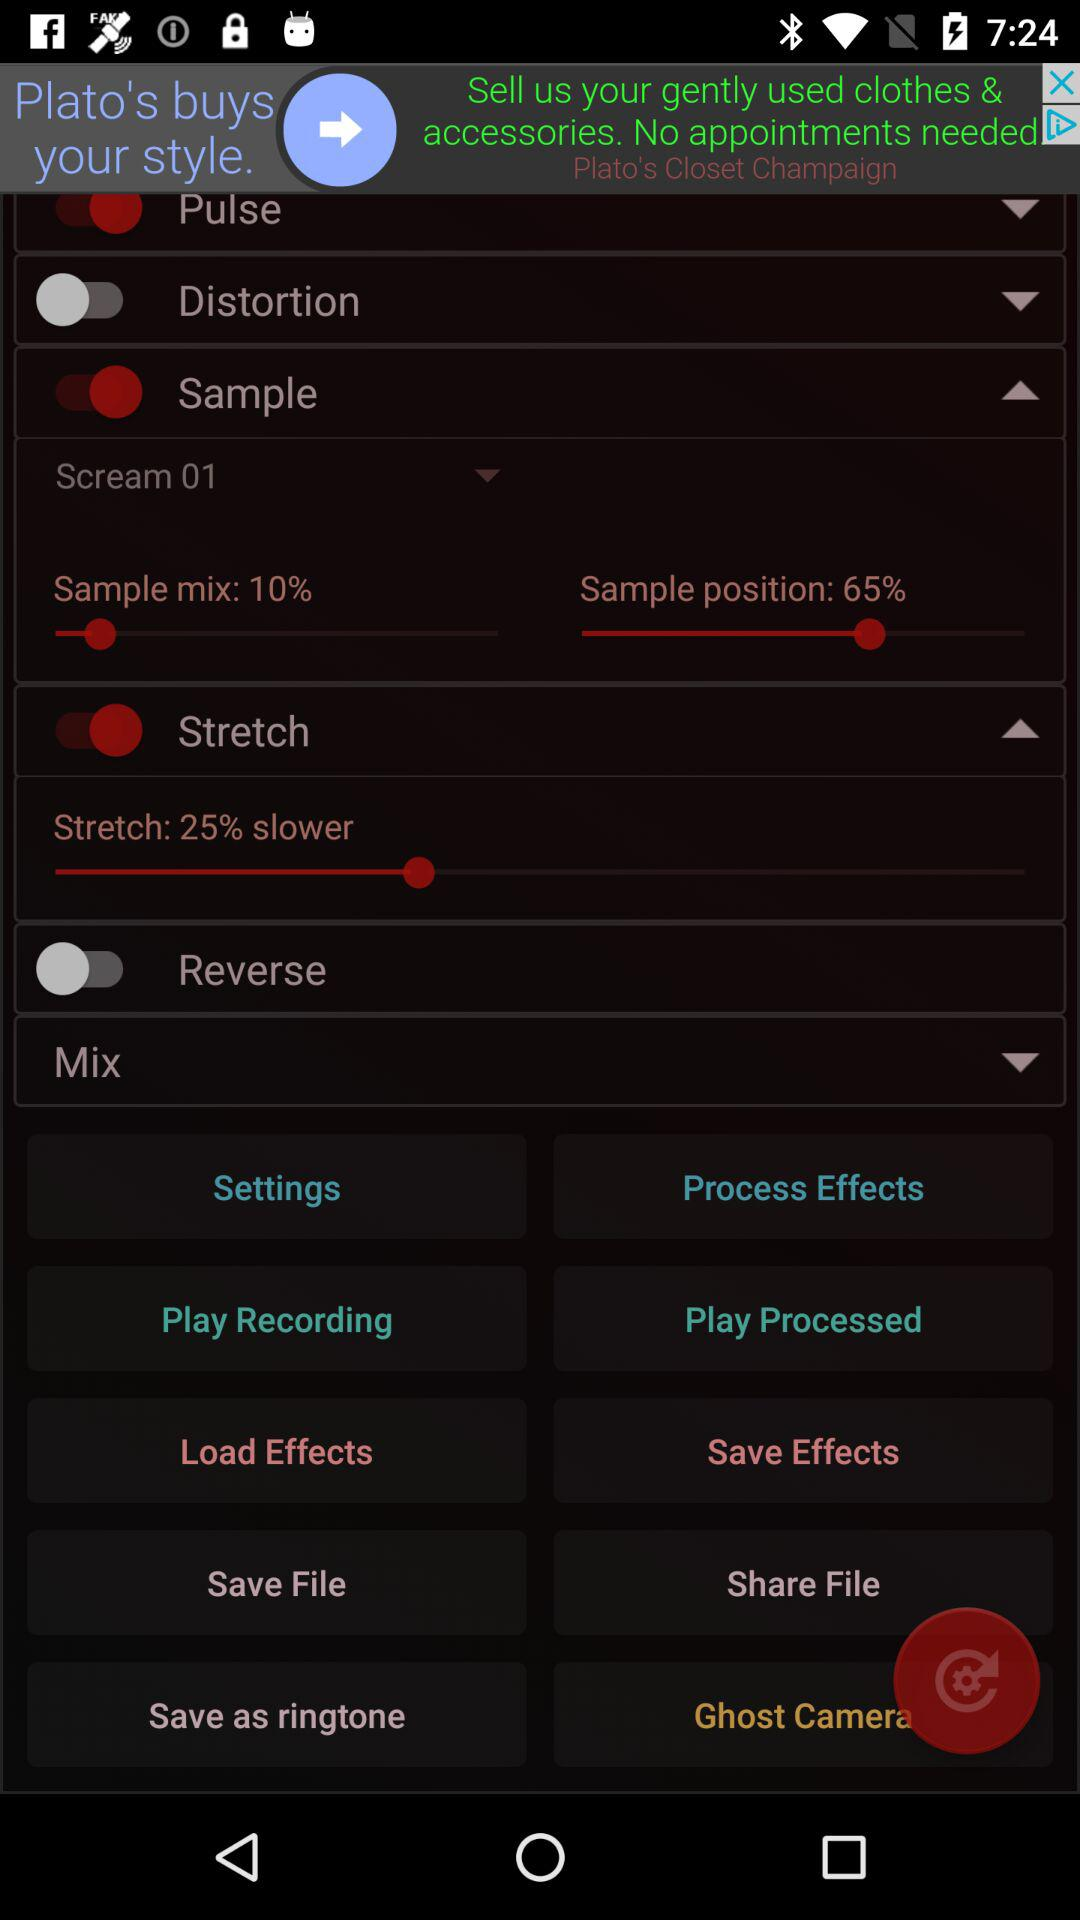What is the percentage of "Sample position"? The sample position is 65%. 